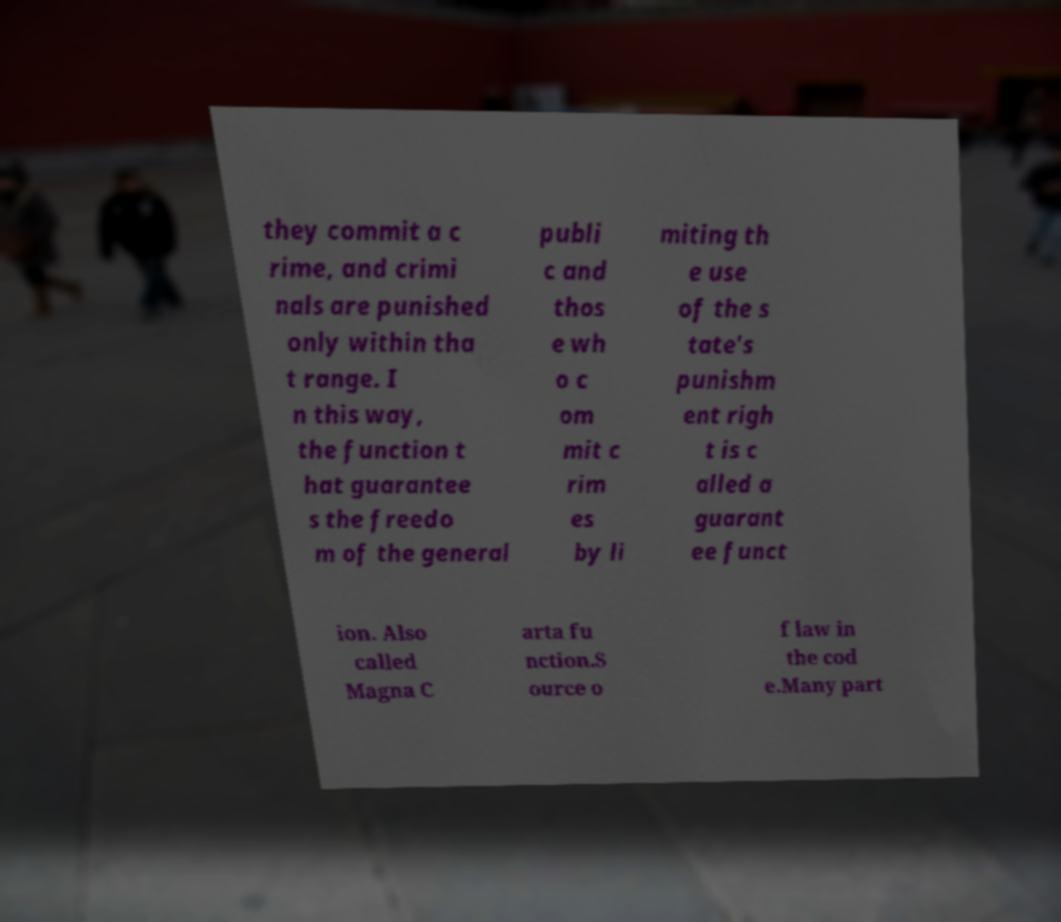There's text embedded in this image that I need extracted. Can you transcribe it verbatim? they commit a c rime, and crimi nals are punished only within tha t range. I n this way, the function t hat guarantee s the freedo m of the general publi c and thos e wh o c om mit c rim es by li miting th e use of the s tate's punishm ent righ t is c alled a guarant ee funct ion. Also called Magna C arta fu nction.S ource o f law in the cod e.Many part 